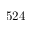<formula> <loc_0><loc_0><loc_500><loc_500>5 2 4</formula> 